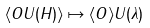Convert formula to latex. <formula><loc_0><loc_0><loc_500><loc_500>\langle O U ( H ) \rangle \mapsto \langle O \rangle U ( \lambda )</formula> 